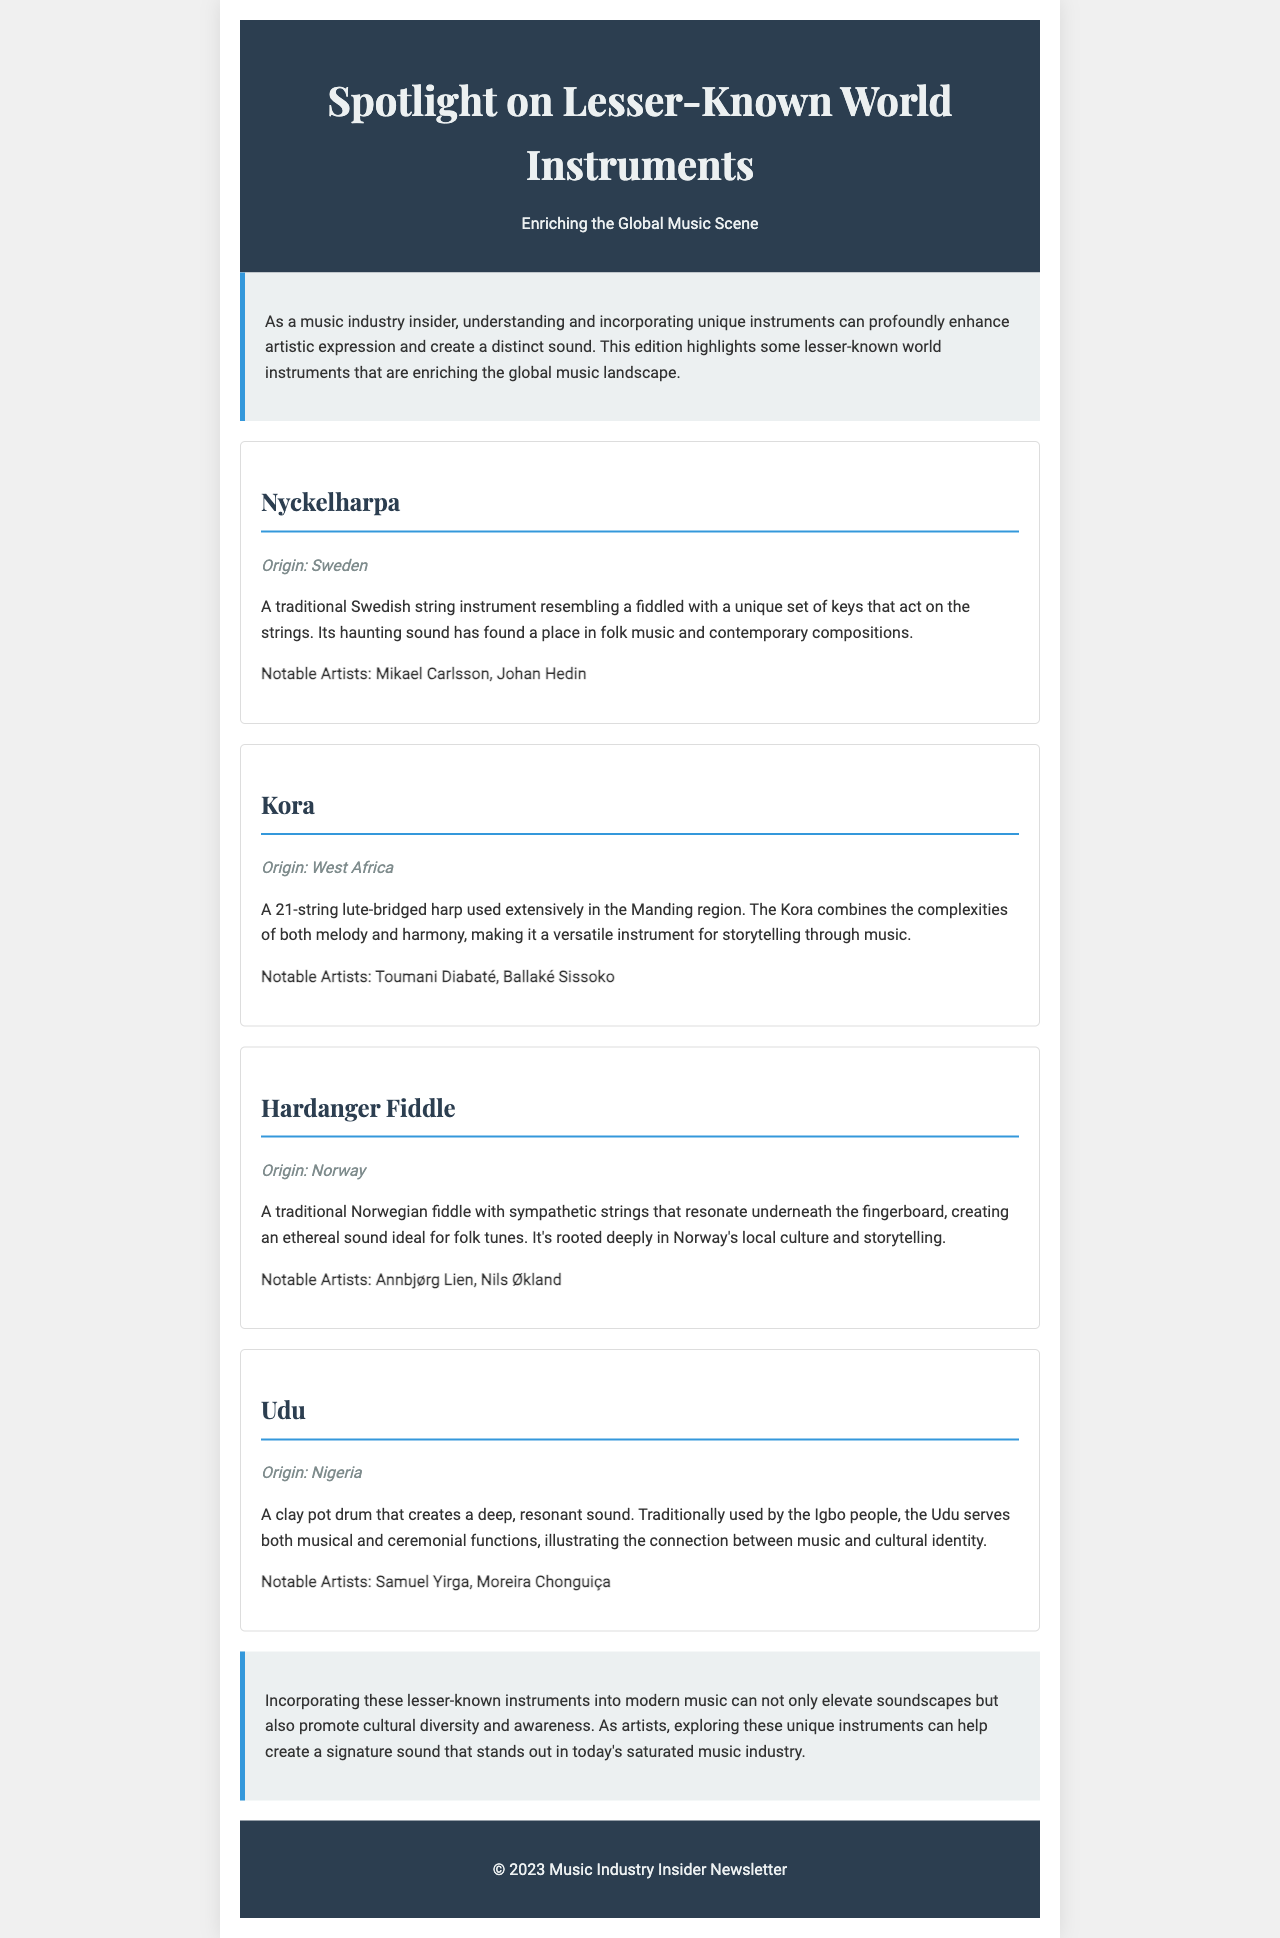What is the title of the newsletter? The title of the newsletter is stated in the header section of the document.
Answer: Spotlight on Lesser-Known World Instruments Which instrument originates from Sweden? The specific instrument is mentioned in the document along with its origin.
Answer: Nyckelharpa How many strings does the Kora have? The document specifies the number of strings in the Kora description.
Answer: 21 Who is a notable artist associated with the Udu? The document mentions notable artists related to the Udu instrument in its section.
Answer: Samuel Yirga What is the main purpose of incorporating lesser-known instruments into modern music? The conclusion section highlights the purpose of incorporating these instruments.
Answer: Promote cultural diversity and awareness Which instrument is described as having sympathetic strings? The document provides descriptions of instruments with specific characteristics.
Answer: Hardanger Fiddle What type of instrument is the Udu? The document categorizes the Udu and explains its characteristics.
Answer: Clay pot drum Which country is the origin of the Hardanger Fiddle? The origin of the Hardanger Fiddle is mentioned in its respective section.
Answer: Norway 